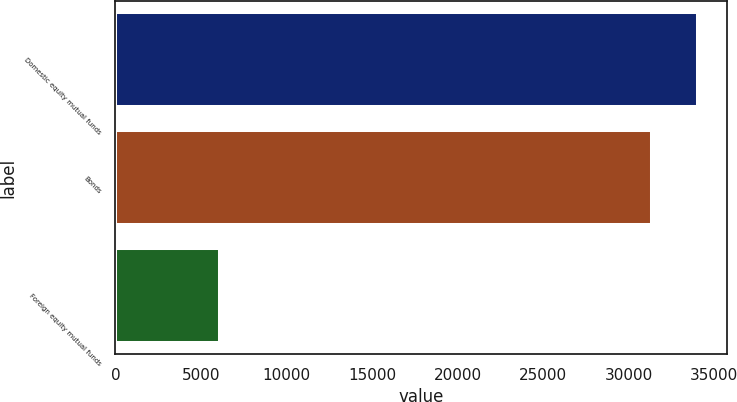<chart> <loc_0><loc_0><loc_500><loc_500><bar_chart><fcel>Domestic equity mutual funds<fcel>Bonds<fcel>Foreign equity mutual funds<nl><fcel>34036.1<fcel>31394<fcel>6100<nl></chart> 